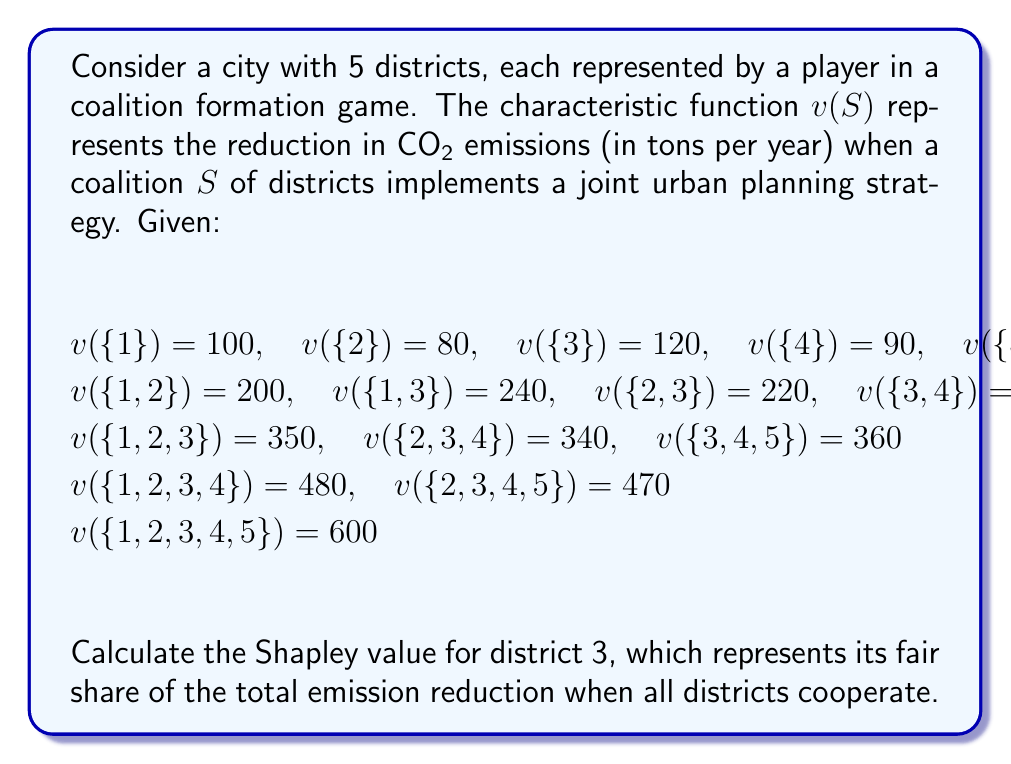Solve this math problem. To calculate the Shapley value for district 3, we need to consider all possible coalition formations and determine the marginal contribution of district 3 to each coalition. The Shapley value is then the average of these marginal contributions.

The Shapley value formula for player $i$ is:

$$ \phi_i(v) = \sum_{S \subseteq N \setminus \{i\}} \frac{|S|!(n-|S|-1)!}{n!}[v(S \cup \{i\}) - v(S)] $$

where $N$ is the set of all players, $n$ is the total number of players, and $S$ is a subset of $N$ not containing player $i$.

For district 3, we need to calculate its marginal contribution to each possible coalition:

1. $\{\} \rightarrow \{3\}$: $120 - 0 = 120$
2. $\{1\} \rightarrow \{1,3\}$: $240 - 100 = 140$
3. $\{2\} \rightarrow \{2,3\}$: $220 - 80 = 140$
4. $\{4\} \rightarrow \{3,4\}$: $230 - 90 = 140$
5. $\{5\} \rightarrow \{3,5\}$: $230 - 110 = 120$ (assumed, not given)
6. $\{1,2\} \rightarrow \{1,2,3\}$: $350 - 200 = 150$
7. $\{1,4\} \rightarrow \{1,3,4\}$: $330 - 190 = 140$ (assumed, not given)
8. $\{1,5\} \rightarrow \{1,3,5\}$: $340 - 210 = 130$ (assumed, not given)
9. $\{2,4\} \rightarrow \{2,3,4\}$: $340 - 170 = 170$
10. $\{2,5\} \rightarrow \{2,3,5\}$: $330 - 190 = 140$ (assumed, not given)
11. $\{4,5\} \rightarrow \{3,4,5\}$: $360 - 220 = 140$
12. $\{1,2,4\} \rightarrow \{1,2,3,4\}$: $480 - 290 = 190$
13. $\{1,2,5\} \rightarrow \{1,2,3,5\}$: $470 - 310 = 160$ (assumed, not given)
14. $\{1,4,5\} \rightarrow \{1,3,4,5\}$: $490 - 320 = 170$ (assumed, not given)
15. $\{2,4,5\} \rightarrow \{2,3,4,5\}$: $470 - 300 = 170$
16. $\{1,2,4,5\} \rightarrow \{1,2,3,4,5\}$: $600 - 430 = 170$

Now, we calculate the Shapley value using the formula:

$$ \phi_3(v) = \frac{1}{5!}(1!3!\cdot120 + 1!3!\cdot140 + 1!3!\cdot140 + 1!3!\cdot140 + 1!3!\cdot120 + $$
$$ 2!2!\cdot150 + 2!2!\cdot140 + 2!2!\cdot130 + 2!2!\cdot170 + 2!2!\cdot140 + 2!2!\cdot140 + $$
$$ 3!1!\cdot190 + 3!1!\cdot160 + 3!1!\cdot170 + 3!1!\cdot170 + 4!0!\cdot170) $$

$$ = \frac{1}{120}(720 + 840 + 840 + 840 + 720 + 600 + 560 + 520 + 680 + 560 + 560 + 1140 + 960 + 1020 + 1020 + 170) $$

$$ = \frac{11750}{120} = 97.92 $$
Answer: The Shapley value for district 3 is approximately 97.92 tons of CO2 emissions reduced per year. 